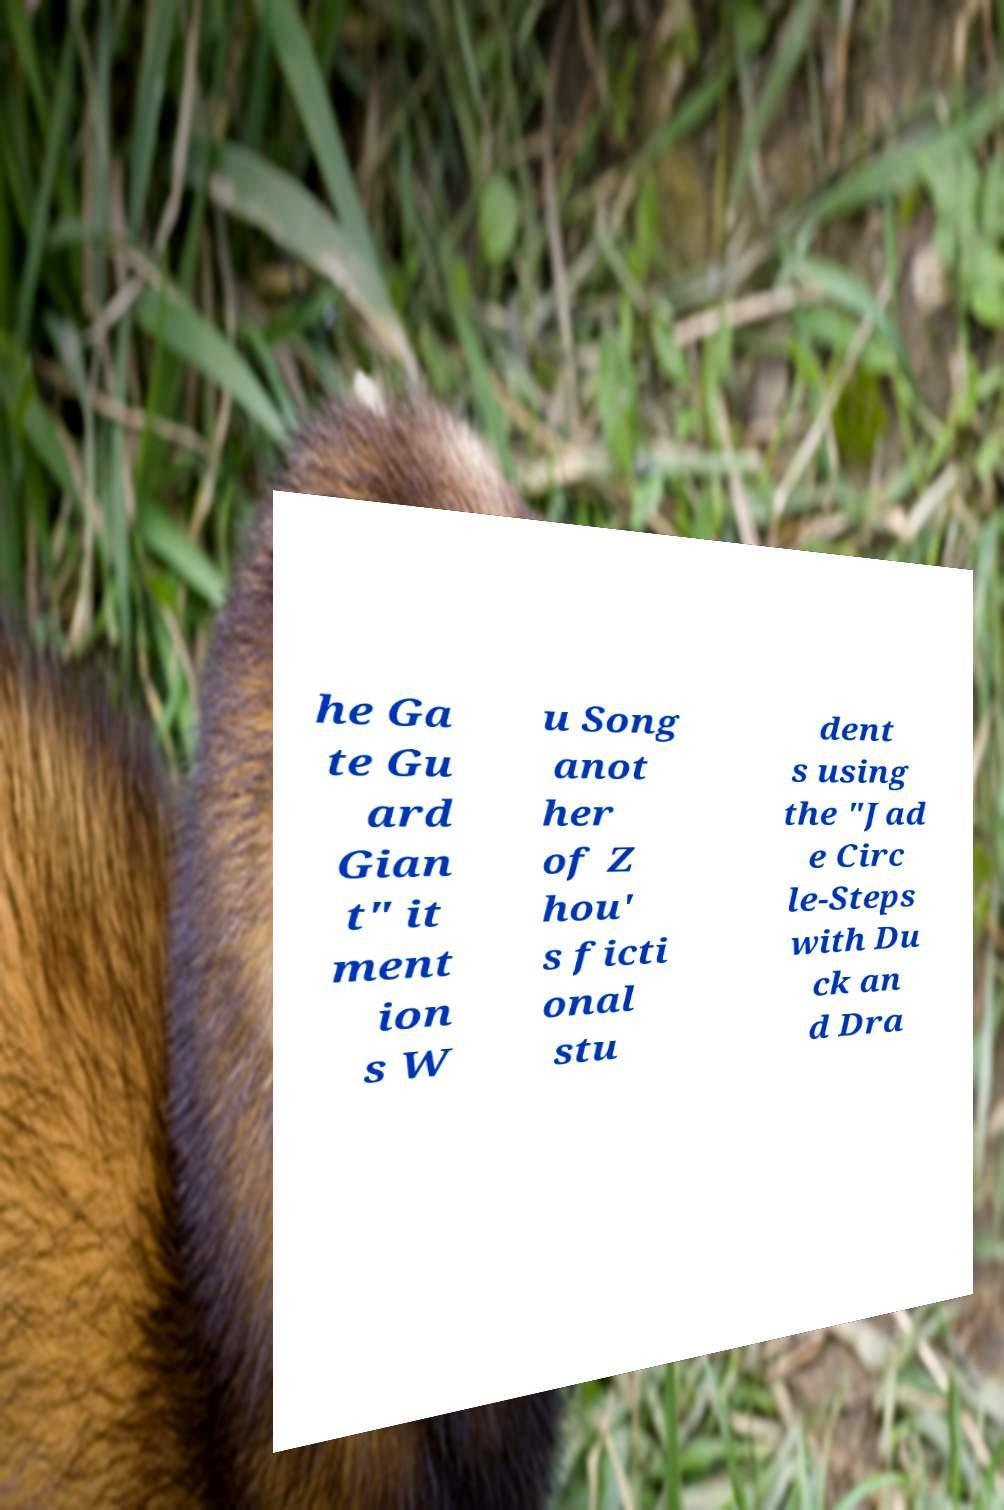There's text embedded in this image that I need extracted. Can you transcribe it verbatim? he Ga te Gu ard Gian t" it ment ion s W u Song anot her of Z hou' s ficti onal stu dent s using the "Jad e Circ le-Steps with Du ck an d Dra 